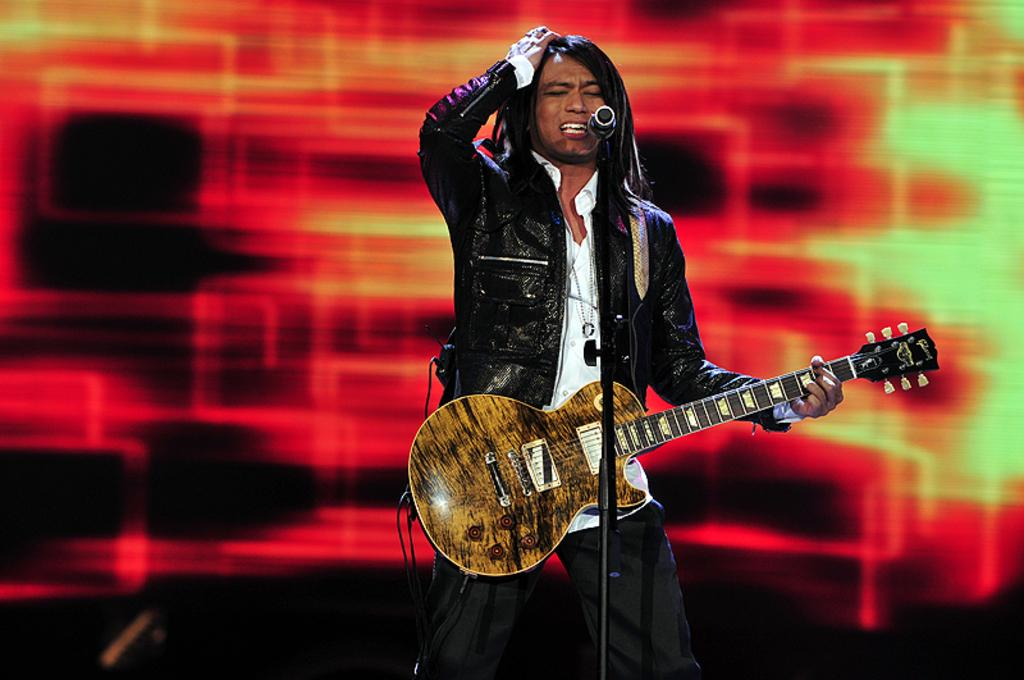What is the person in the image doing? The person is standing and singing in the image. What object is the person holding? The person is holding a guitar. What device is present for amplifying the person's voice? There is a microphone with a stand in the image. What type of beast can be seen playing with a rake in the image? There is no beast or rake present in the image; it features a person singing with a guitar and a microphone with a stand. What kind of pot is being used to cook the person's meal? There is no meal or pot present in the image; it only shows a person singing with a guitar and a microphone with a stand. 